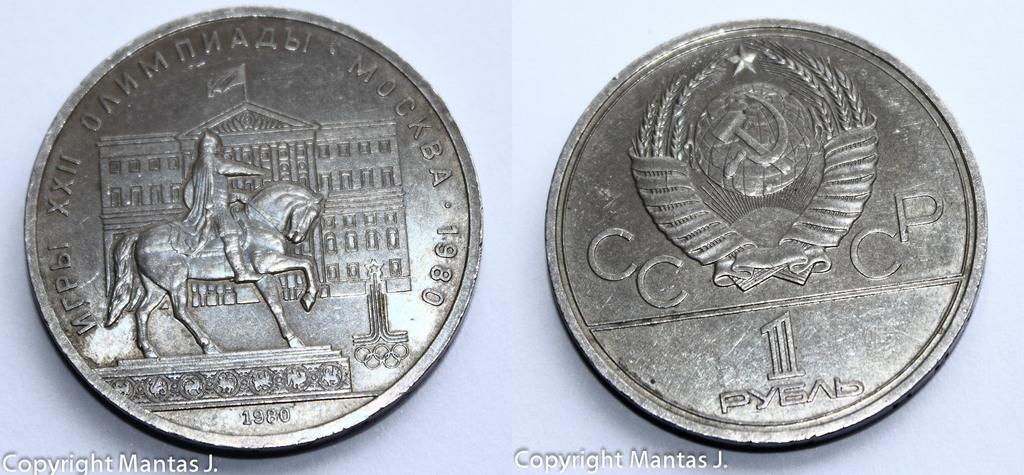<image>
Describe the image concisely. two silver coins with one of them that says cc and cp on it 